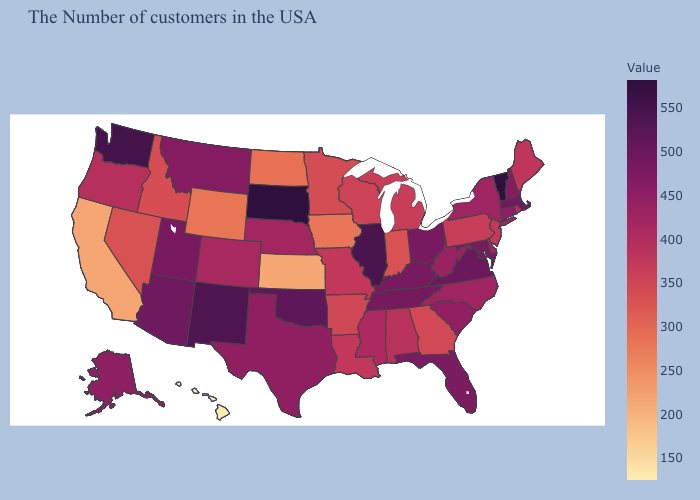Does Pennsylvania have a higher value than Florida?
Answer briefly. No. Does the map have missing data?
Quick response, please. No. Is the legend a continuous bar?
Be succinct. Yes. 